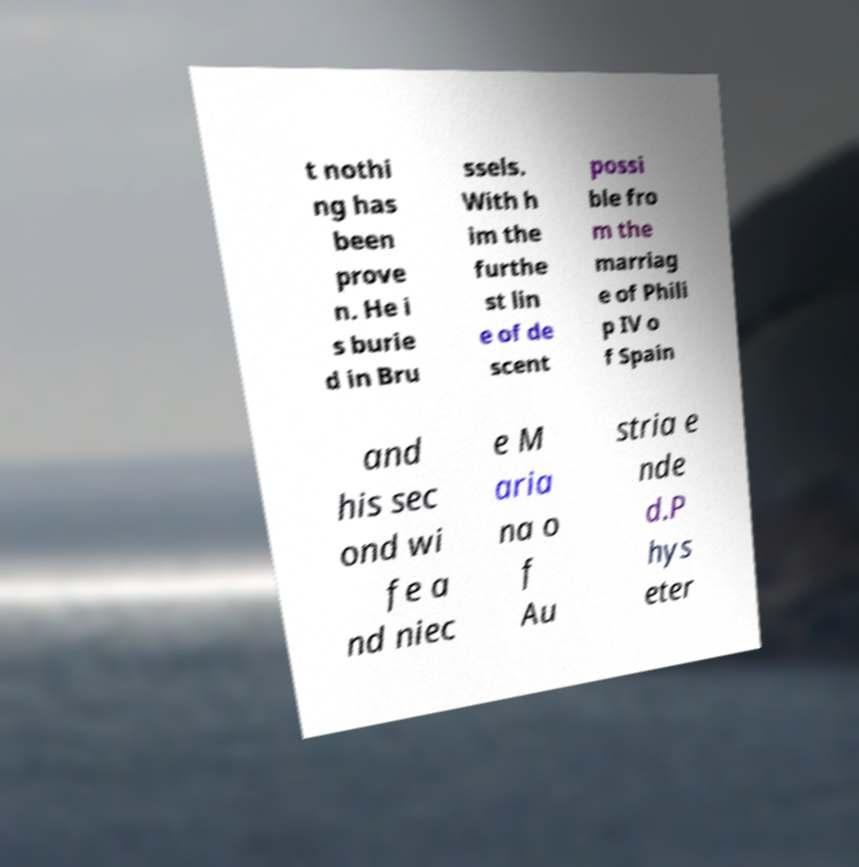I need the written content from this picture converted into text. Can you do that? t nothi ng has been prove n. He i s burie d in Bru ssels. With h im the furthe st lin e of de scent possi ble fro m the marriag e of Phili p IV o f Spain and his sec ond wi fe a nd niec e M aria na o f Au stria e nde d.P hys eter 